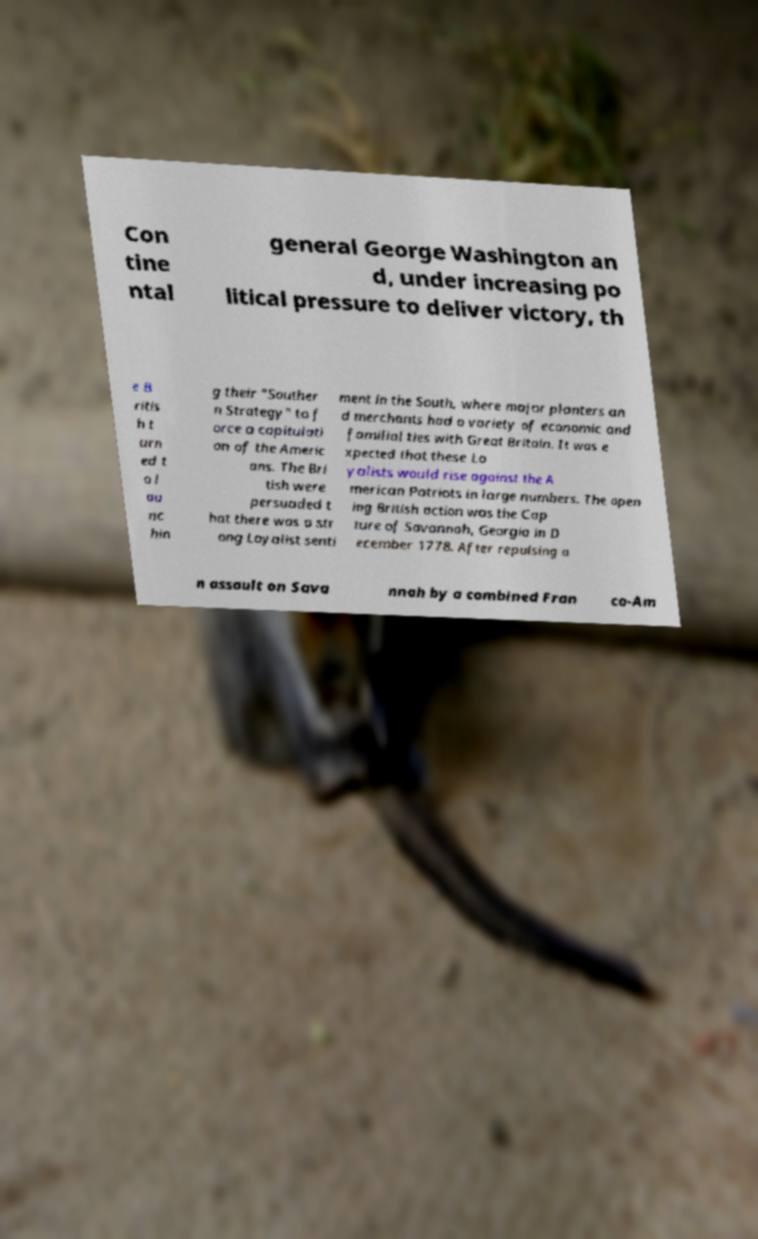I need the written content from this picture converted into text. Can you do that? Con tine ntal general George Washington an d, under increasing po litical pressure to deliver victory, th e B ritis h t urn ed t o l au nc hin g their "Souther n Strategy" to f orce a capitulati on of the Americ ans. The Bri tish were persuaded t hat there was a str ong Loyalist senti ment in the South, where major planters an d merchants had a variety of economic and familial ties with Great Britain. It was e xpected that these Lo yalists would rise against the A merican Patriots in large numbers. The open ing British action was the Cap ture of Savannah, Georgia in D ecember 1778. After repulsing a n assault on Sava nnah by a combined Fran co-Am 